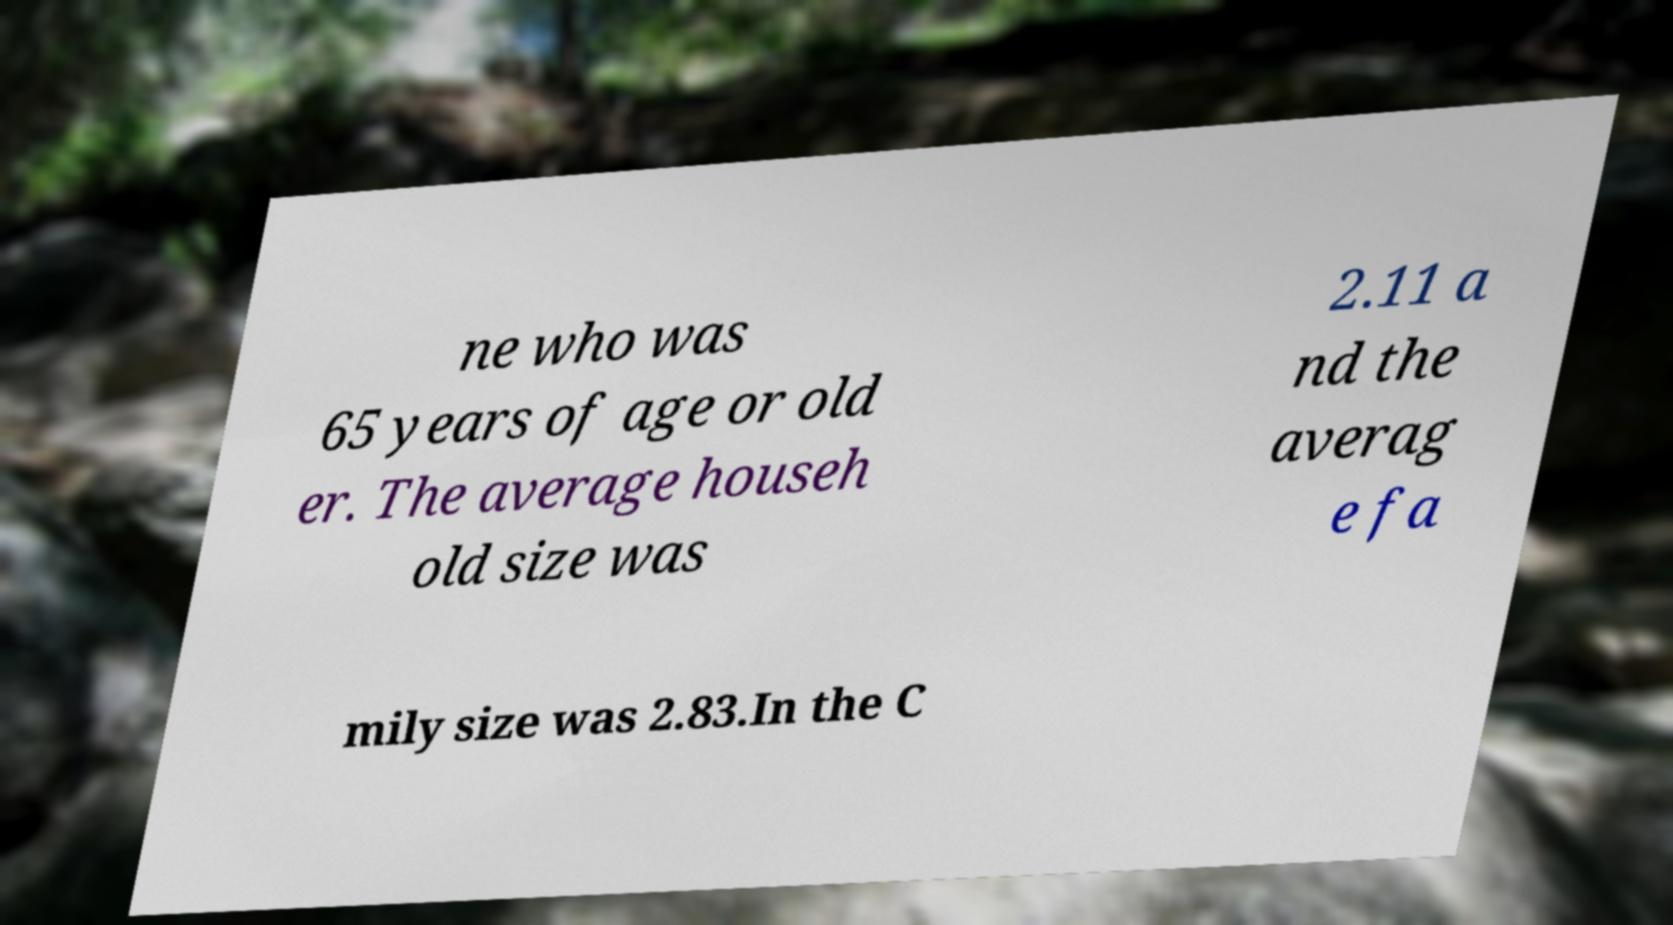Could you assist in decoding the text presented in this image and type it out clearly? ne who was 65 years of age or old er. The average househ old size was 2.11 a nd the averag e fa mily size was 2.83.In the C 